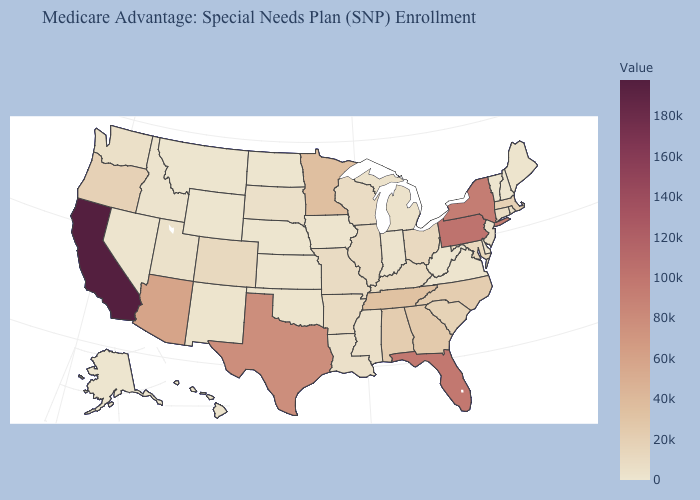Among the states that border Tennessee , which have the lowest value?
Keep it brief. Virginia. Does Idaho have the highest value in the USA?
Be succinct. No. Does Iowa have a lower value than Florida?
Write a very short answer. Yes. Does the map have missing data?
Keep it brief. No. Which states have the highest value in the USA?
Give a very brief answer. California. Which states hav the highest value in the Northeast?
Short answer required. Pennsylvania. 